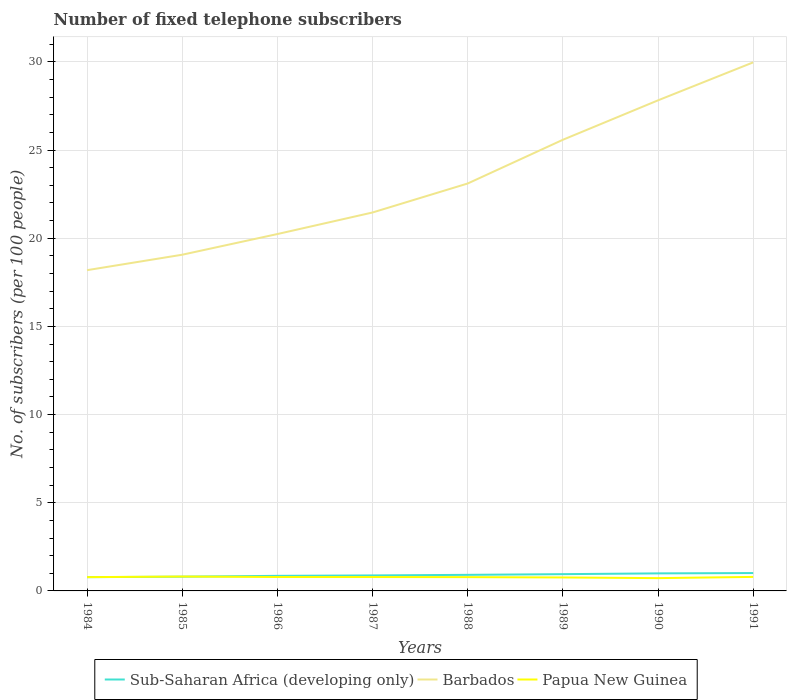Across all years, what is the maximum number of fixed telephone subscribers in Papua New Guinea?
Offer a terse response. 0.73. What is the total number of fixed telephone subscribers in Barbados in the graph?
Your response must be concise. -4.04. What is the difference between the highest and the second highest number of fixed telephone subscribers in Sub-Saharan Africa (developing only)?
Your answer should be compact. 0.23. What is the difference between the highest and the lowest number of fixed telephone subscribers in Barbados?
Your answer should be very brief. 3. Is the number of fixed telephone subscribers in Barbados strictly greater than the number of fixed telephone subscribers in Sub-Saharan Africa (developing only) over the years?
Make the answer very short. No. Are the values on the major ticks of Y-axis written in scientific E-notation?
Ensure brevity in your answer.  No. Does the graph contain grids?
Your answer should be very brief. Yes. How many legend labels are there?
Your response must be concise. 3. How are the legend labels stacked?
Offer a terse response. Horizontal. What is the title of the graph?
Provide a short and direct response. Number of fixed telephone subscribers. Does "Maldives" appear as one of the legend labels in the graph?
Your response must be concise. No. What is the label or title of the X-axis?
Your answer should be compact. Years. What is the label or title of the Y-axis?
Keep it short and to the point. No. of subscribers (per 100 people). What is the No. of subscribers (per 100 people) of Sub-Saharan Africa (developing only) in 1984?
Provide a short and direct response. 0.78. What is the No. of subscribers (per 100 people) in Barbados in 1984?
Keep it short and to the point. 18.19. What is the No. of subscribers (per 100 people) in Papua New Guinea in 1984?
Your answer should be compact. 0.78. What is the No. of subscribers (per 100 people) of Sub-Saharan Africa (developing only) in 1985?
Provide a succinct answer. 0.81. What is the No. of subscribers (per 100 people) in Barbados in 1985?
Your response must be concise. 19.06. What is the No. of subscribers (per 100 people) of Papua New Guinea in 1985?
Provide a succinct answer. 0.82. What is the No. of subscribers (per 100 people) of Sub-Saharan Africa (developing only) in 1986?
Offer a very short reply. 0.86. What is the No. of subscribers (per 100 people) in Barbados in 1986?
Keep it short and to the point. 20.24. What is the No. of subscribers (per 100 people) in Papua New Guinea in 1986?
Ensure brevity in your answer.  0.79. What is the No. of subscribers (per 100 people) of Sub-Saharan Africa (developing only) in 1987?
Make the answer very short. 0.88. What is the No. of subscribers (per 100 people) in Barbados in 1987?
Your answer should be very brief. 21.46. What is the No. of subscribers (per 100 people) of Papua New Guinea in 1987?
Offer a very short reply. 0.79. What is the No. of subscribers (per 100 people) of Sub-Saharan Africa (developing only) in 1988?
Your answer should be compact. 0.91. What is the No. of subscribers (per 100 people) of Barbados in 1988?
Offer a terse response. 23.1. What is the No. of subscribers (per 100 people) in Papua New Guinea in 1988?
Your response must be concise. 0.78. What is the No. of subscribers (per 100 people) in Sub-Saharan Africa (developing only) in 1989?
Ensure brevity in your answer.  0.95. What is the No. of subscribers (per 100 people) of Barbados in 1989?
Provide a short and direct response. 25.58. What is the No. of subscribers (per 100 people) of Papua New Guinea in 1989?
Give a very brief answer. 0.76. What is the No. of subscribers (per 100 people) of Sub-Saharan Africa (developing only) in 1990?
Your response must be concise. 1. What is the No. of subscribers (per 100 people) in Barbados in 1990?
Provide a succinct answer. 27.82. What is the No. of subscribers (per 100 people) in Papua New Guinea in 1990?
Your answer should be compact. 0.73. What is the No. of subscribers (per 100 people) in Sub-Saharan Africa (developing only) in 1991?
Your response must be concise. 1.01. What is the No. of subscribers (per 100 people) in Barbados in 1991?
Provide a short and direct response. 29.97. What is the No. of subscribers (per 100 people) in Papua New Guinea in 1991?
Your answer should be compact. 0.79. Across all years, what is the maximum No. of subscribers (per 100 people) in Sub-Saharan Africa (developing only)?
Your response must be concise. 1.01. Across all years, what is the maximum No. of subscribers (per 100 people) in Barbados?
Keep it short and to the point. 29.97. Across all years, what is the maximum No. of subscribers (per 100 people) in Papua New Guinea?
Offer a very short reply. 0.82. Across all years, what is the minimum No. of subscribers (per 100 people) in Sub-Saharan Africa (developing only)?
Your answer should be very brief. 0.78. Across all years, what is the minimum No. of subscribers (per 100 people) in Barbados?
Keep it short and to the point. 18.19. Across all years, what is the minimum No. of subscribers (per 100 people) of Papua New Guinea?
Provide a succinct answer. 0.73. What is the total No. of subscribers (per 100 people) in Sub-Saharan Africa (developing only) in the graph?
Give a very brief answer. 7.19. What is the total No. of subscribers (per 100 people) in Barbados in the graph?
Keep it short and to the point. 185.42. What is the total No. of subscribers (per 100 people) in Papua New Guinea in the graph?
Give a very brief answer. 6.24. What is the difference between the No. of subscribers (per 100 people) of Sub-Saharan Africa (developing only) in 1984 and that in 1985?
Ensure brevity in your answer.  -0.03. What is the difference between the No. of subscribers (per 100 people) in Barbados in 1984 and that in 1985?
Your answer should be compact. -0.88. What is the difference between the No. of subscribers (per 100 people) of Papua New Guinea in 1984 and that in 1985?
Make the answer very short. -0.03. What is the difference between the No. of subscribers (per 100 people) in Sub-Saharan Africa (developing only) in 1984 and that in 1986?
Your response must be concise. -0.07. What is the difference between the No. of subscribers (per 100 people) in Barbados in 1984 and that in 1986?
Offer a very short reply. -2.05. What is the difference between the No. of subscribers (per 100 people) of Papua New Guinea in 1984 and that in 1986?
Your answer should be compact. -0.01. What is the difference between the No. of subscribers (per 100 people) of Sub-Saharan Africa (developing only) in 1984 and that in 1987?
Provide a succinct answer. -0.1. What is the difference between the No. of subscribers (per 100 people) of Barbados in 1984 and that in 1987?
Give a very brief answer. -3.27. What is the difference between the No. of subscribers (per 100 people) of Papua New Guinea in 1984 and that in 1987?
Provide a succinct answer. -0.01. What is the difference between the No. of subscribers (per 100 people) in Sub-Saharan Africa (developing only) in 1984 and that in 1988?
Your answer should be very brief. -0.13. What is the difference between the No. of subscribers (per 100 people) in Barbados in 1984 and that in 1988?
Offer a very short reply. -4.91. What is the difference between the No. of subscribers (per 100 people) in Papua New Guinea in 1984 and that in 1988?
Give a very brief answer. -0. What is the difference between the No. of subscribers (per 100 people) in Sub-Saharan Africa (developing only) in 1984 and that in 1989?
Your response must be concise. -0.17. What is the difference between the No. of subscribers (per 100 people) of Barbados in 1984 and that in 1989?
Offer a very short reply. -7.39. What is the difference between the No. of subscribers (per 100 people) of Papua New Guinea in 1984 and that in 1989?
Your answer should be compact. 0.02. What is the difference between the No. of subscribers (per 100 people) of Sub-Saharan Africa (developing only) in 1984 and that in 1990?
Offer a very short reply. -0.21. What is the difference between the No. of subscribers (per 100 people) of Barbados in 1984 and that in 1990?
Provide a short and direct response. -9.63. What is the difference between the No. of subscribers (per 100 people) of Papua New Guinea in 1984 and that in 1990?
Your answer should be very brief. 0.06. What is the difference between the No. of subscribers (per 100 people) of Sub-Saharan Africa (developing only) in 1984 and that in 1991?
Your answer should be compact. -0.23. What is the difference between the No. of subscribers (per 100 people) in Barbados in 1984 and that in 1991?
Provide a succinct answer. -11.78. What is the difference between the No. of subscribers (per 100 people) in Papua New Guinea in 1984 and that in 1991?
Offer a very short reply. -0.01. What is the difference between the No. of subscribers (per 100 people) of Sub-Saharan Africa (developing only) in 1985 and that in 1986?
Provide a short and direct response. -0.05. What is the difference between the No. of subscribers (per 100 people) of Barbados in 1985 and that in 1986?
Your answer should be compact. -1.17. What is the difference between the No. of subscribers (per 100 people) of Papua New Guinea in 1985 and that in 1986?
Ensure brevity in your answer.  0.03. What is the difference between the No. of subscribers (per 100 people) in Sub-Saharan Africa (developing only) in 1985 and that in 1987?
Offer a terse response. -0.07. What is the difference between the No. of subscribers (per 100 people) in Barbados in 1985 and that in 1987?
Ensure brevity in your answer.  -2.39. What is the difference between the No. of subscribers (per 100 people) of Papua New Guinea in 1985 and that in 1987?
Your answer should be compact. 0.03. What is the difference between the No. of subscribers (per 100 people) of Sub-Saharan Africa (developing only) in 1985 and that in 1988?
Your answer should be very brief. -0.1. What is the difference between the No. of subscribers (per 100 people) in Barbados in 1985 and that in 1988?
Provide a short and direct response. -4.04. What is the difference between the No. of subscribers (per 100 people) in Papua New Guinea in 1985 and that in 1988?
Offer a terse response. 0.03. What is the difference between the No. of subscribers (per 100 people) of Sub-Saharan Africa (developing only) in 1985 and that in 1989?
Ensure brevity in your answer.  -0.14. What is the difference between the No. of subscribers (per 100 people) in Barbados in 1985 and that in 1989?
Ensure brevity in your answer.  -6.52. What is the difference between the No. of subscribers (per 100 people) of Papua New Guinea in 1985 and that in 1989?
Give a very brief answer. 0.05. What is the difference between the No. of subscribers (per 100 people) in Sub-Saharan Africa (developing only) in 1985 and that in 1990?
Make the answer very short. -0.19. What is the difference between the No. of subscribers (per 100 people) in Barbados in 1985 and that in 1990?
Give a very brief answer. -8.75. What is the difference between the No. of subscribers (per 100 people) in Papua New Guinea in 1985 and that in 1990?
Offer a very short reply. 0.09. What is the difference between the No. of subscribers (per 100 people) in Sub-Saharan Africa (developing only) in 1985 and that in 1991?
Provide a short and direct response. -0.21. What is the difference between the No. of subscribers (per 100 people) in Barbados in 1985 and that in 1991?
Ensure brevity in your answer.  -10.91. What is the difference between the No. of subscribers (per 100 people) of Papua New Guinea in 1985 and that in 1991?
Your response must be concise. 0.02. What is the difference between the No. of subscribers (per 100 people) in Sub-Saharan Africa (developing only) in 1986 and that in 1987?
Offer a very short reply. -0.02. What is the difference between the No. of subscribers (per 100 people) in Barbados in 1986 and that in 1987?
Provide a short and direct response. -1.22. What is the difference between the No. of subscribers (per 100 people) in Papua New Guinea in 1986 and that in 1987?
Provide a short and direct response. 0. What is the difference between the No. of subscribers (per 100 people) of Sub-Saharan Africa (developing only) in 1986 and that in 1988?
Give a very brief answer. -0.06. What is the difference between the No. of subscribers (per 100 people) of Barbados in 1986 and that in 1988?
Ensure brevity in your answer.  -2.87. What is the difference between the No. of subscribers (per 100 people) in Papua New Guinea in 1986 and that in 1988?
Keep it short and to the point. 0.01. What is the difference between the No. of subscribers (per 100 people) of Sub-Saharan Africa (developing only) in 1986 and that in 1989?
Your response must be concise. -0.1. What is the difference between the No. of subscribers (per 100 people) of Barbados in 1986 and that in 1989?
Your response must be concise. -5.35. What is the difference between the No. of subscribers (per 100 people) of Papua New Guinea in 1986 and that in 1989?
Offer a very short reply. 0.02. What is the difference between the No. of subscribers (per 100 people) in Sub-Saharan Africa (developing only) in 1986 and that in 1990?
Offer a very short reply. -0.14. What is the difference between the No. of subscribers (per 100 people) in Barbados in 1986 and that in 1990?
Keep it short and to the point. -7.58. What is the difference between the No. of subscribers (per 100 people) of Papua New Guinea in 1986 and that in 1990?
Give a very brief answer. 0.06. What is the difference between the No. of subscribers (per 100 people) of Sub-Saharan Africa (developing only) in 1986 and that in 1991?
Ensure brevity in your answer.  -0.16. What is the difference between the No. of subscribers (per 100 people) in Barbados in 1986 and that in 1991?
Your answer should be compact. -9.74. What is the difference between the No. of subscribers (per 100 people) in Papua New Guinea in 1986 and that in 1991?
Make the answer very short. -0.01. What is the difference between the No. of subscribers (per 100 people) of Sub-Saharan Africa (developing only) in 1987 and that in 1988?
Offer a very short reply. -0.03. What is the difference between the No. of subscribers (per 100 people) of Barbados in 1987 and that in 1988?
Offer a terse response. -1.64. What is the difference between the No. of subscribers (per 100 people) of Papua New Guinea in 1987 and that in 1988?
Your answer should be compact. 0. What is the difference between the No. of subscribers (per 100 people) in Sub-Saharan Africa (developing only) in 1987 and that in 1989?
Ensure brevity in your answer.  -0.07. What is the difference between the No. of subscribers (per 100 people) of Barbados in 1987 and that in 1989?
Make the answer very short. -4.12. What is the difference between the No. of subscribers (per 100 people) of Papua New Guinea in 1987 and that in 1989?
Provide a short and direct response. 0.02. What is the difference between the No. of subscribers (per 100 people) of Sub-Saharan Africa (developing only) in 1987 and that in 1990?
Offer a very short reply. -0.12. What is the difference between the No. of subscribers (per 100 people) in Barbados in 1987 and that in 1990?
Offer a very short reply. -6.36. What is the difference between the No. of subscribers (per 100 people) in Papua New Guinea in 1987 and that in 1990?
Offer a terse response. 0.06. What is the difference between the No. of subscribers (per 100 people) in Sub-Saharan Africa (developing only) in 1987 and that in 1991?
Your answer should be compact. -0.13. What is the difference between the No. of subscribers (per 100 people) in Barbados in 1987 and that in 1991?
Offer a terse response. -8.51. What is the difference between the No. of subscribers (per 100 people) in Papua New Guinea in 1987 and that in 1991?
Offer a terse response. -0.01. What is the difference between the No. of subscribers (per 100 people) of Sub-Saharan Africa (developing only) in 1988 and that in 1989?
Offer a terse response. -0.04. What is the difference between the No. of subscribers (per 100 people) in Barbados in 1988 and that in 1989?
Offer a terse response. -2.48. What is the difference between the No. of subscribers (per 100 people) of Papua New Guinea in 1988 and that in 1989?
Give a very brief answer. 0.02. What is the difference between the No. of subscribers (per 100 people) of Sub-Saharan Africa (developing only) in 1988 and that in 1990?
Offer a terse response. -0.08. What is the difference between the No. of subscribers (per 100 people) in Barbados in 1988 and that in 1990?
Give a very brief answer. -4.72. What is the difference between the No. of subscribers (per 100 people) of Papua New Guinea in 1988 and that in 1990?
Your response must be concise. 0.06. What is the difference between the No. of subscribers (per 100 people) of Sub-Saharan Africa (developing only) in 1988 and that in 1991?
Make the answer very short. -0.1. What is the difference between the No. of subscribers (per 100 people) of Barbados in 1988 and that in 1991?
Your response must be concise. -6.87. What is the difference between the No. of subscribers (per 100 people) in Papua New Guinea in 1988 and that in 1991?
Your response must be concise. -0.01. What is the difference between the No. of subscribers (per 100 people) of Sub-Saharan Africa (developing only) in 1989 and that in 1990?
Your answer should be compact. -0.04. What is the difference between the No. of subscribers (per 100 people) of Barbados in 1989 and that in 1990?
Your response must be concise. -2.24. What is the difference between the No. of subscribers (per 100 people) of Papua New Guinea in 1989 and that in 1990?
Your answer should be very brief. 0.04. What is the difference between the No. of subscribers (per 100 people) of Sub-Saharan Africa (developing only) in 1989 and that in 1991?
Offer a terse response. -0.06. What is the difference between the No. of subscribers (per 100 people) in Barbados in 1989 and that in 1991?
Provide a succinct answer. -4.39. What is the difference between the No. of subscribers (per 100 people) in Papua New Guinea in 1989 and that in 1991?
Your answer should be compact. -0.03. What is the difference between the No. of subscribers (per 100 people) in Sub-Saharan Africa (developing only) in 1990 and that in 1991?
Make the answer very short. -0.02. What is the difference between the No. of subscribers (per 100 people) of Barbados in 1990 and that in 1991?
Your answer should be compact. -2.15. What is the difference between the No. of subscribers (per 100 people) in Papua New Guinea in 1990 and that in 1991?
Your response must be concise. -0.07. What is the difference between the No. of subscribers (per 100 people) of Sub-Saharan Africa (developing only) in 1984 and the No. of subscribers (per 100 people) of Barbados in 1985?
Your answer should be compact. -18.28. What is the difference between the No. of subscribers (per 100 people) in Sub-Saharan Africa (developing only) in 1984 and the No. of subscribers (per 100 people) in Papua New Guinea in 1985?
Your answer should be very brief. -0.03. What is the difference between the No. of subscribers (per 100 people) in Barbados in 1984 and the No. of subscribers (per 100 people) in Papua New Guinea in 1985?
Keep it short and to the point. 17.37. What is the difference between the No. of subscribers (per 100 people) of Sub-Saharan Africa (developing only) in 1984 and the No. of subscribers (per 100 people) of Barbados in 1986?
Offer a terse response. -19.45. What is the difference between the No. of subscribers (per 100 people) of Sub-Saharan Africa (developing only) in 1984 and the No. of subscribers (per 100 people) of Papua New Guinea in 1986?
Offer a very short reply. -0.01. What is the difference between the No. of subscribers (per 100 people) in Barbados in 1984 and the No. of subscribers (per 100 people) in Papua New Guinea in 1986?
Offer a very short reply. 17.4. What is the difference between the No. of subscribers (per 100 people) in Sub-Saharan Africa (developing only) in 1984 and the No. of subscribers (per 100 people) in Barbados in 1987?
Offer a very short reply. -20.68. What is the difference between the No. of subscribers (per 100 people) of Sub-Saharan Africa (developing only) in 1984 and the No. of subscribers (per 100 people) of Papua New Guinea in 1987?
Your answer should be very brief. -0.01. What is the difference between the No. of subscribers (per 100 people) in Barbados in 1984 and the No. of subscribers (per 100 people) in Papua New Guinea in 1987?
Your answer should be very brief. 17.4. What is the difference between the No. of subscribers (per 100 people) in Sub-Saharan Africa (developing only) in 1984 and the No. of subscribers (per 100 people) in Barbados in 1988?
Your answer should be compact. -22.32. What is the difference between the No. of subscribers (per 100 people) of Sub-Saharan Africa (developing only) in 1984 and the No. of subscribers (per 100 people) of Papua New Guinea in 1988?
Offer a terse response. -0. What is the difference between the No. of subscribers (per 100 people) of Barbados in 1984 and the No. of subscribers (per 100 people) of Papua New Guinea in 1988?
Provide a short and direct response. 17.41. What is the difference between the No. of subscribers (per 100 people) of Sub-Saharan Africa (developing only) in 1984 and the No. of subscribers (per 100 people) of Barbados in 1989?
Give a very brief answer. -24.8. What is the difference between the No. of subscribers (per 100 people) in Sub-Saharan Africa (developing only) in 1984 and the No. of subscribers (per 100 people) in Papua New Guinea in 1989?
Keep it short and to the point. 0.02. What is the difference between the No. of subscribers (per 100 people) of Barbados in 1984 and the No. of subscribers (per 100 people) of Papua New Guinea in 1989?
Make the answer very short. 17.42. What is the difference between the No. of subscribers (per 100 people) in Sub-Saharan Africa (developing only) in 1984 and the No. of subscribers (per 100 people) in Barbados in 1990?
Provide a short and direct response. -27.04. What is the difference between the No. of subscribers (per 100 people) of Sub-Saharan Africa (developing only) in 1984 and the No. of subscribers (per 100 people) of Papua New Guinea in 1990?
Make the answer very short. 0.05. What is the difference between the No. of subscribers (per 100 people) in Barbados in 1984 and the No. of subscribers (per 100 people) in Papua New Guinea in 1990?
Give a very brief answer. 17.46. What is the difference between the No. of subscribers (per 100 people) of Sub-Saharan Africa (developing only) in 1984 and the No. of subscribers (per 100 people) of Barbados in 1991?
Provide a succinct answer. -29.19. What is the difference between the No. of subscribers (per 100 people) of Sub-Saharan Africa (developing only) in 1984 and the No. of subscribers (per 100 people) of Papua New Guinea in 1991?
Ensure brevity in your answer.  -0.01. What is the difference between the No. of subscribers (per 100 people) in Barbados in 1984 and the No. of subscribers (per 100 people) in Papua New Guinea in 1991?
Provide a short and direct response. 17.39. What is the difference between the No. of subscribers (per 100 people) of Sub-Saharan Africa (developing only) in 1985 and the No. of subscribers (per 100 people) of Barbados in 1986?
Your answer should be compact. -19.43. What is the difference between the No. of subscribers (per 100 people) in Sub-Saharan Africa (developing only) in 1985 and the No. of subscribers (per 100 people) in Papua New Guinea in 1986?
Keep it short and to the point. 0.02. What is the difference between the No. of subscribers (per 100 people) in Barbados in 1985 and the No. of subscribers (per 100 people) in Papua New Guinea in 1986?
Offer a very short reply. 18.27. What is the difference between the No. of subscribers (per 100 people) of Sub-Saharan Africa (developing only) in 1985 and the No. of subscribers (per 100 people) of Barbados in 1987?
Make the answer very short. -20.65. What is the difference between the No. of subscribers (per 100 people) in Sub-Saharan Africa (developing only) in 1985 and the No. of subscribers (per 100 people) in Papua New Guinea in 1987?
Offer a very short reply. 0.02. What is the difference between the No. of subscribers (per 100 people) in Barbados in 1985 and the No. of subscribers (per 100 people) in Papua New Guinea in 1987?
Give a very brief answer. 18.28. What is the difference between the No. of subscribers (per 100 people) of Sub-Saharan Africa (developing only) in 1985 and the No. of subscribers (per 100 people) of Barbados in 1988?
Make the answer very short. -22.29. What is the difference between the No. of subscribers (per 100 people) of Sub-Saharan Africa (developing only) in 1985 and the No. of subscribers (per 100 people) of Papua New Guinea in 1988?
Offer a very short reply. 0.03. What is the difference between the No. of subscribers (per 100 people) of Barbados in 1985 and the No. of subscribers (per 100 people) of Papua New Guinea in 1988?
Ensure brevity in your answer.  18.28. What is the difference between the No. of subscribers (per 100 people) in Sub-Saharan Africa (developing only) in 1985 and the No. of subscribers (per 100 people) in Barbados in 1989?
Offer a terse response. -24.77. What is the difference between the No. of subscribers (per 100 people) of Sub-Saharan Africa (developing only) in 1985 and the No. of subscribers (per 100 people) of Papua New Guinea in 1989?
Your answer should be very brief. 0.04. What is the difference between the No. of subscribers (per 100 people) of Barbados in 1985 and the No. of subscribers (per 100 people) of Papua New Guinea in 1989?
Offer a very short reply. 18.3. What is the difference between the No. of subscribers (per 100 people) in Sub-Saharan Africa (developing only) in 1985 and the No. of subscribers (per 100 people) in Barbados in 1990?
Provide a succinct answer. -27.01. What is the difference between the No. of subscribers (per 100 people) in Sub-Saharan Africa (developing only) in 1985 and the No. of subscribers (per 100 people) in Papua New Guinea in 1990?
Provide a succinct answer. 0.08. What is the difference between the No. of subscribers (per 100 people) of Barbados in 1985 and the No. of subscribers (per 100 people) of Papua New Guinea in 1990?
Provide a short and direct response. 18.34. What is the difference between the No. of subscribers (per 100 people) in Sub-Saharan Africa (developing only) in 1985 and the No. of subscribers (per 100 people) in Barbados in 1991?
Provide a short and direct response. -29.16. What is the difference between the No. of subscribers (per 100 people) in Sub-Saharan Africa (developing only) in 1985 and the No. of subscribers (per 100 people) in Papua New Guinea in 1991?
Provide a succinct answer. 0.01. What is the difference between the No. of subscribers (per 100 people) of Barbados in 1985 and the No. of subscribers (per 100 people) of Papua New Guinea in 1991?
Your answer should be very brief. 18.27. What is the difference between the No. of subscribers (per 100 people) of Sub-Saharan Africa (developing only) in 1986 and the No. of subscribers (per 100 people) of Barbados in 1987?
Your answer should be compact. -20.6. What is the difference between the No. of subscribers (per 100 people) of Sub-Saharan Africa (developing only) in 1986 and the No. of subscribers (per 100 people) of Papua New Guinea in 1987?
Your answer should be very brief. 0.07. What is the difference between the No. of subscribers (per 100 people) in Barbados in 1986 and the No. of subscribers (per 100 people) in Papua New Guinea in 1987?
Give a very brief answer. 19.45. What is the difference between the No. of subscribers (per 100 people) in Sub-Saharan Africa (developing only) in 1986 and the No. of subscribers (per 100 people) in Barbados in 1988?
Offer a terse response. -22.25. What is the difference between the No. of subscribers (per 100 people) in Sub-Saharan Africa (developing only) in 1986 and the No. of subscribers (per 100 people) in Papua New Guinea in 1988?
Provide a short and direct response. 0.07. What is the difference between the No. of subscribers (per 100 people) in Barbados in 1986 and the No. of subscribers (per 100 people) in Papua New Guinea in 1988?
Provide a succinct answer. 19.45. What is the difference between the No. of subscribers (per 100 people) of Sub-Saharan Africa (developing only) in 1986 and the No. of subscribers (per 100 people) of Barbados in 1989?
Give a very brief answer. -24.73. What is the difference between the No. of subscribers (per 100 people) of Sub-Saharan Africa (developing only) in 1986 and the No. of subscribers (per 100 people) of Papua New Guinea in 1989?
Your response must be concise. 0.09. What is the difference between the No. of subscribers (per 100 people) in Barbados in 1986 and the No. of subscribers (per 100 people) in Papua New Guinea in 1989?
Your answer should be very brief. 19.47. What is the difference between the No. of subscribers (per 100 people) in Sub-Saharan Africa (developing only) in 1986 and the No. of subscribers (per 100 people) in Barbados in 1990?
Your answer should be compact. -26.96. What is the difference between the No. of subscribers (per 100 people) of Sub-Saharan Africa (developing only) in 1986 and the No. of subscribers (per 100 people) of Papua New Guinea in 1990?
Your response must be concise. 0.13. What is the difference between the No. of subscribers (per 100 people) in Barbados in 1986 and the No. of subscribers (per 100 people) in Papua New Guinea in 1990?
Your response must be concise. 19.51. What is the difference between the No. of subscribers (per 100 people) in Sub-Saharan Africa (developing only) in 1986 and the No. of subscribers (per 100 people) in Barbados in 1991?
Give a very brief answer. -29.12. What is the difference between the No. of subscribers (per 100 people) of Sub-Saharan Africa (developing only) in 1986 and the No. of subscribers (per 100 people) of Papua New Guinea in 1991?
Offer a terse response. 0.06. What is the difference between the No. of subscribers (per 100 people) of Barbados in 1986 and the No. of subscribers (per 100 people) of Papua New Guinea in 1991?
Your response must be concise. 19.44. What is the difference between the No. of subscribers (per 100 people) of Sub-Saharan Africa (developing only) in 1987 and the No. of subscribers (per 100 people) of Barbados in 1988?
Make the answer very short. -22.22. What is the difference between the No. of subscribers (per 100 people) in Sub-Saharan Africa (developing only) in 1987 and the No. of subscribers (per 100 people) in Papua New Guinea in 1988?
Provide a short and direct response. 0.1. What is the difference between the No. of subscribers (per 100 people) in Barbados in 1987 and the No. of subscribers (per 100 people) in Papua New Guinea in 1988?
Give a very brief answer. 20.68. What is the difference between the No. of subscribers (per 100 people) of Sub-Saharan Africa (developing only) in 1987 and the No. of subscribers (per 100 people) of Barbados in 1989?
Ensure brevity in your answer.  -24.7. What is the difference between the No. of subscribers (per 100 people) in Sub-Saharan Africa (developing only) in 1987 and the No. of subscribers (per 100 people) in Papua New Guinea in 1989?
Offer a very short reply. 0.12. What is the difference between the No. of subscribers (per 100 people) in Barbados in 1987 and the No. of subscribers (per 100 people) in Papua New Guinea in 1989?
Your answer should be compact. 20.69. What is the difference between the No. of subscribers (per 100 people) in Sub-Saharan Africa (developing only) in 1987 and the No. of subscribers (per 100 people) in Barbados in 1990?
Offer a very short reply. -26.94. What is the difference between the No. of subscribers (per 100 people) in Sub-Saharan Africa (developing only) in 1987 and the No. of subscribers (per 100 people) in Papua New Guinea in 1990?
Your answer should be compact. 0.15. What is the difference between the No. of subscribers (per 100 people) in Barbados in 1987 and the No. of subscribers (per 100 people) in Papua New Guinea in 1990?
Your response must be concise. 20.73. What is the difference between the No. of subscribers (per 100 people) of Sub-Saharan Africa (developing only) in 1987 and the No. of subscribers (per 100 people) of Barbados in 1991?
Your answer should be compact. -29.09. What is the difference between the No. of subscribers (per 100 people) of Sub-Saharan Africa (developing only) in 1987 and the No. of subscribers (per 100 people) of Papua New Guinea in 1991?
Keep it short and to the point. 0.08. What is the difference between the No. of subscribers (per 100 people) in Barbados in 1987 and the No. of subscribers (per 100 people) in Papua New Guinea in 1991?
Your answer should be very brief. 20.66. What is the difference between the No. of subscribers (per 100 people) in Sub-Saharan Africa (developing only) in 1988 and the No. of subscribers (per 100 people) in Barbados in 1989?
Make the answer very short. -24.67. What is the difference between the No. of subscribers (per 100 people) in Sub-Saharan Africa (developing only) in 1988 and the No. of subscribers (per 100 people) in Papua New Guinea in 1989?
Provide a succinct answer. 0.15. What is the difference between the No. of subscribers (per 100 people) of Barbados in 1988 and the No. of subscribers (per 100 people) of Papua New Guinea in 1989?
Make the answer very short. 22.34. What is the difference between the No. of subscribers (per 100 people) of Sub-Saharan Africa (developing only) in 1988 and the No. of subscribers (per 100 people) of Barbados in 1990?
Keep it short and to the point. -26.91. What is the difference between the No. of subscribers (per 100 people) in Sub-Saharan Africa (developing only) in 1988 and the No. of subscribers (per 100 people) in Papua New Guinea in 1990?
Make the answer very short. 0.19. What is the difference between the No. of subscribers (per 100 people) in Barbados in 1988 and the No. of subscribers (per 100 people) in Papua New Guinea in 1990?
Offer a terse response. 22.38. What is the difference between the No. of subscribers (per 100 people) of Sub-Saharan Africa (developing only) in 1988 and the No. of subscribers (per 100 people) of Barbados in 1991?
Offer a terse response. -29.06. What is the difference between the No. of subscribers (per 100 people) of Sub-Saharan Africa (developing only) in 1988 and the No. of subscribers (per 100 people) of Papua New Guinea in 1991?
Keep it short and to the point. 0.12. What is the difference between the No. of subscribers (per 100 people) of Barbados in 1988 and the No. of subscribers (per 100 people) of Papua New Guinea in 1991?
Offer a very short reply. 22.31. What is the difference between the No. of subscribers (per 100 people) of Sub-Saharan Africa (developing only) in 1989 and the No. of subscribers (per 100 people) of Barbados in 1990?
Make the answer very short. -26.87. What is the difference between the No. of subscribers (per 100 people) in Sub-Saharan Africa (developing only) in 1989 and the No. of subscribers (per 100 people) in Papua New Guinea in 1990?
Your answer should be compact. 0.22. What is the difference between the No. of subscribers (per 100 people) in Barbados in 1989 and the No. of subscribers (per 100 people) in Papua New Guinea in 1990?
Your response must be concise. 24.86. What is the difference between the No. of subscribers (per 100 people) of Sub-Saharan Africa (developing only) in 1989 and the No. of subscribers (per 100 people) of Barbados in 1991?
Provide a succinct answer. -29.02. What is the difference between the No. of subscribers (per 100 people) of Sub-Saharan Africa (developing only) in 1989 and the No. of subscribers (per 100 people) of Papua New Guinea in 1991?
Ensure brevity in your answer.  0.16. What is the difference between the No. of subscribers (per 100 people) of Barbados in 1989 and the No. of subscribers (per 100 people) of Papua New Guinea in 1991?
Keep it short and to the point. 24.79. What is the difference between the No. of subscribers (per 100 people) of Sub-Saharan Africa (developing only) in 1990 and the No. of subscribers (per 100 people) of Barbados in 1991?
Provide a succinct answer. -28.98. What is the difference between the No. of subscribers (per 100 people) in Sub-Saharan Africa (developing only) in 1990 and the No. of subscribers (per 100 people) in Papua New Guinea in 1991?
Provide a short and direct response. 0.2. What is the difference between the No. of subscribers (per 100 people) in Barbados in 1990 and the No. of subscribers (per 100 people) in Papua New Guinea in 1991?
Ensure brevity in your answer.  27.02. What is the average No. of subscribers (per 100 people) in Sub-Saharan Africa (developing only) per year?
Offer a very short reply. 0.9. What is the average No. of subscribers (per 100 people) in Barbados per year?
Offer a terse response. 23.18. What is the average No. of subscribers (per 100 people) of Papua New Guinea per year?
Provide a succinct answer. 0.78. In the year 1984, what is the difference between the No. of subscribers (per 100 people) in Sub-Saharan Africa (developing only) and No. of subscribers (per 100 people) in Barbados?
Your response must be concise. -17.41. In the year 1984, what is the difference between the No. of subscribers (per 100 people) of Sub-Saharan Africa (developing only) and No. of subscribers (per 100 people) of Papua New Guinea?
Offer a very short reply. -0. In the year 1984, what is the difference between the No. of subscribers (per 100 people) in Barbados and No. of subscribers (per 100 people) in Papua New Guinea?
Provide a short and direct response. 17.41. In the year 1985, what is the difference between the No. of subscribers (per 100 people) in Sub-Saharan Africa (developing only) and No. of subscribers (per 100 people) in Barbados?
Your answer should be very brief. -18.26. In the year 1985, what is the difference between the No. of subscribers (per 100 people) in Sub-Saharan Africa (developing only) and No. of subscribers (per 100 people) in Papua New Guinea?
Provide a short and direct response. -0.01. In the year 1985, what is the difference between the No. of subscribers (per 100 people) in Barbados and No. of subscribers (per 100 people) in Papua New Guinea?
Make the answer very short. 18.25. In the year 1986, what is the difference between the No. of subscribers (per 100 people) of Sub-Saharan Africa (developing only) and No. of subscribers (per 100 people) of Barbados?
Ensure brevity in your answer.  -19.38. In the year 1986, what is the difference between the No. of subscribers (per 100 people) in Sub-Saharan Africa (developing only) and No. of subscribers (per 100 people) in Papua New Guinea?
Offer a very short reply. 0.07. In the year 1986, what is the difference between the No. of subscribers (per 100 people) in Barbados and No. of subscribers (per 100 people) in Papua New Guinea?
Your response must be concise. 19.45. In the year 1987, what is the difference between the No. of subscribers (per 100 people) of Sub-Saharan Africa (developing only) and No. of subscribers (per 100 people) of Barbados?
Offer a terse response. -20.58. In the year 1987, what is the difference between the No. of subscribers (per 100 people) in Sub-Saharan Africa (developing only) and No. of subscribers (per 100 people) in Papua New Guinea?
Your answer should be compact. 0.09. In the year 1987, what is the difference between the No. of subscribers (per 100 people) of Barbados and No. of subscribers (per 100 people) of Papua New Guinea?
Ensure brevity in your answer.  20.67. In the year 1988, what is the difference between the No. of subscribers (per 100 people) in Sub-Saharan Africa (developing only) and No. of subscribers (per 100 people) in Barbados?
Your answer should be very brief. -22.19. In the year 1988, what is the difference between the No. of subscribers (per 100 people) in Sub-Saharan Africa (developing only) and No. of subscribers (per 100 people) in Papua New Guinea?
Ensure brevity in your answer.  0.13. In the year 1988, what is the difference between the No. of subscribers (per 100 people) in Barbados and No. of subscribers (per 100 people) in Papua New Guinea?
Offer a very short reply. 22.32. In the year 1989, what is the difference between the No. of subscribers (per 100 people) of Sub-Saharan Africa (developing only) and No. of subscribers (per 100 people) of Barbados?
Keep it short and to the point. -24.63. In the year 1989, what is the difference between the No. of subscribers (per 100 people) of Sub-Saharan Africa (developing only) and No. of subscribers (per 100 people) of Papua New Guinea?
Make the answer very short. 0.19. In the year 1989, what is the difference between the No. of subscribers (per 100 people) of Barbados and No. of subscribers (per 100 people) of Papua New Guinea?
Offer a terse response. 24.82. In the year 1990, what is the difference between the No. of subscribers (per 100 people) in Sub-Saharan Africa (developing only) and No. of subscribers (per 100 people) in Barbados?
Offer a terse response. -26.82. In the year 1990, what is the difference between the No. of subscribers (per 100 people) of Sub-Saharan Africa (developing only) and No. of subscribers (per 100 people) of Papua New Guinea?
Keep it short and to the point. 0.27. In the year 1990, what is the difference between the No. of subscribers (per 100 people) of Barbados and No. of subscribers (per 100 people) of Papua New Guinea?
Provide a short and direct response. 27.09. In the year 1991, what is the difference between the No. of subscribers (per 100 people) of Sub-Saharan Africa (developing only) and No. of subscribers (per 100 people) of Barbados?
Your answer should be very brief. -28.96. In the year 1991, what is the difference between the No. of subscribers (per 100 people) of Sub-Saharan Africa (developing only) and No. of subscribers (per 100 people) of Papua New Guinea?
Your response must be concise. 0.22. In the year 1991, what is the difference between the No. of subscribers (per 100 people) in Barbados and No. of subscribers (per 100 people) in Papua New Guinea?
Offer a terse response. 29.18. What is the ratio of the No. of subscribers (per 100 people) in Sub-Saharan Africa (developing only) in 1984 to that in 1985?
Provide a succinct answer. 0.97. What is the ratio of the No. of subscribers (per 100 people) in Barbados in 1984 to that in 1985?
Give a very brief answer. 0.95. What is the ratio of the No. of subscribers (per 100 people) in Papua New Guinea in 1984 to that in 1985?
Ensure brevity in your answer.  0.96. What is the ratio of the No. of subscribers (per 100 people) of Sub-Saharan Africa (developing only) in 1984 to that in 1986?
Give a very brief answer. 0.91. What is the ratio of the No. of subscribers (per 100 people) of Barbados in 1984 to that in 1986?
Keep it short and to the point. 0.9. What is the ratio of the No. of subscribers (per 100 people) in Sub-Saharan Africa (developing only) in 1984 to that in 1987?
Provide a succinct answer. 0.89. What is the ratio of the No. of subscribers (per 100 people) in Barbados in 1984 to that in 1987?
Ensure brevity in your answer.  0.85. What is the ratio of the No. of subscribers (per 100 people) of Sub-Saharan Africa (developing only) in 1984 to that in 1988?
Offer a very short reply. 0.86. What is the ratio of the No. of subscribers (per 100 people) of Barbados in 1984 to that in 1988?
Make the answer very short. 0.79. What is the ratio of the No. of subscribers (per 100 people) in Sub-Saharan Africa (developing only) in 1984 to that in 1989?
Offer a terse response. 0.82. What is the ratio of the No. of subscribers (per 100 people) in Barbados in 1984 to that in 1989?
Offer a very short reply. 0.71. What is the ratio of the No. of subscribers (per 100 people) in Papua New Guinea in 1984 to that in 1989?
Provide a succinct answer. 1.02. What is the ratio of the No. of subscribers (per 100 people) in Sub-Saharan Africa (developing only) in 1984 to that in 1990?
Keep it short and to the point. 0.78. What is the ratio of the No. of subscribers (per 100 people) of Barbados in 1984 to that in 1990?
Provide a succinct answer. 0.65. What is the ratio of the No. of subscribers (per 100 people) of Papua New Guinea in 1984 to that in 1990?
Offer a terse response. 1.08. What is the ratio of the No. of subscribers (per 100 people) of Sub-Saharan Africa (developing only) in 1984 to that in 1991?
Make the answer very short. 0.77. What is the ratio of the No. of subscribers (per 100 people) of Barbados in 1984 to that in 1991?
Ensure brevity in your answer.  0.61. What is the ratio of the No. of subscribers (per 100 people) of Papua New Guinea in 1984 to that in 1991?
Give a very brief answer. 0.98. What is the ratio of the No. of subscribers (per 100 people) in Sub-Saharan Africa (developing only) in 1985 to that in 1986?
Offer a very short reply. 0.94. What is the ratio of the No. of subscribers (per 100 people) of Barbados in 1985 to that in 1986?
Your response must be concise. 0.94. What is the ratio of the No. of subscribers (per 100 people) of Papua New Guinea in 1985 to that in 1986?
Your answer should be compact. 1.03. What is the ratio of the No. of subscribers (per 100 people) in Sub-Saharan Africa (developing only) in 1985 to that in 1987?
Keep it short and to the point. 0.92. What is the ratio of the No. of subscribers (per 100 people) in Barbados in 1985 to that in 1987?
Make the answer very short. 0.89. What is the ratio of the No. of subscribers (per 100 people) of Papua New Guinea in 1985 to that in 1987?
Keep it short and to the point. 1.04. What is the ratio of the No. of subscribers (per 100 people) in Sub-Saharan Africa (developing only) in 1985 to that in 1988?
Offer a very short reply. 0.89. What is the ratio of the No. of subscribers (per 100 people) in Barbados in 1985 to that in 1988?
Provide a succinct answer. 0.83. What is the ratio of the No. of subscribers (per 100 people) of Papua New Guinea in 1985 to that in 1988?
Provide a succinct answer. 1.04. What is the ratio of the No. of subscribers (per 100 people) of Sub-Saharan Africa (developing only) in 1985 to that in 1989?
Ensure brevity in your answer.  0.85. What is the ratio of the No. of subscribers (per 100 people) of Barbados in 1985 to that in 1989?
Offer a very short reply. 0.75. What is the ratio of the No. of subscribers (per 100 people) in Papua New Guinea in 1985 to that in 1989?
Provide a short and direct response. 1.07. What is the ratio of the No. of subscribers (per 100 people) of Sub-Saharan Africa (developing only) in 1985 to that in 1990?
Provide a short and direct response. 0.81. What is the ratio of the No. of subscribers (per 100 people) of Barbados in 1985 to that in 1990?
Offer a terse response. 0.69. What is the ratio of the No. of subscribers (per 100 people) in Papua New Guinea in 1985 to that in 1990?
Give a very brief answer. 1.12. What is the ratio of the No. of subscribers (per 100 people) of Sub-Saharan Africa (developing only) in 1985 to that in 1991?
Your answer should be compact. 0.8. What is the ratio of the No. of subscribers (per 100 people) of Barbados in 1985 to that in 1991?
Your response must be concise. 0.64. What is the ratio of the No. of subscribers (per 100 people) of Papua New Guinea in 1985 to that in 1991?
Your answer should be compact. 1.03. What is the ratio of the No. of subscribers (per 100 people) in Sub-Saharan Africa (developing only) in 1986 to that in 1987?
Provide a short and direct response. 0.97. What is the ratio of the No. of subscribers (per 100 people) of Barbados in 1986 to that in 1987?
Your answer should be compact. 0.94. What is the ratio of the No. of subscribers (per 100 people) in Papua New Guinea in 1986 to that in 1987?
Offer a terse response. 1. What is the ratio of the No. of subscribers (per 100 people) of Sub-Saharan Africa (developing only) in 1986 to that in 1988?
Ensure brevity in your answer.  0.94. What is the ratio of the No. of subscribers (per 100 people) in Barbados in 1986 to that in 1988?
Provide a short and direct response. 0.88. What is the ratio of the No. of subscribers (per 100 people) in Papua New Guinea in 1986 to that in 1988?
Give a very brief answer. 1.01. What is the ratio of the No. of subscribers (per 100 people) in Sub-Saharan Africa (developing only) in 1986 to that in 1989?
Give a very brief answer. 0.9. What is the ratio of the No. of subscribers (per 100 people) of Barbados in 1986 to that in 1989?
Your answer should be very brief. 0.79. What is the ratio of the No. of subscribers (per 100 people) of Papua New Guinea in 1986 to that in 1989?
Keep it short and to the point. 1.03. What is the ratio of the No. of subscribers (per 100 people) in Sub-Saharan Africa (developing only) in 1986 to that in 1990?
Make the answer very short. 0.86. What is the ratio of the No. of subscribers (per 100 people) of Barbados in 1986 to that in 1990?
Provide a succinct answer. 0.73. What is the ratio of the No. of subscribers (per 100 people) of Papua New Guinea in 1986 to that in 1990?
Your answer should be compact. 1.09. What is the ratio of the No. of subscribers (per 100 people) of Sub-Saharan Africa (developing only) in 1986 to that in 1991?
Your answer should be very brief. 0.84. What is the ratio of the No. of subscribers (per 100 people) in Barbados in 1986 to that in 1991?
Offer a very short reply. 0.68. What is the ratio of the No. of subscribers (per 100 people) in Sub-Saharan Africa (developing only) in 1987 to that in 1988?
Your answer should be very brief. 0.96. What is the ratio of the No. of subscribers (per 100 people) in Barbados in 1987 to that in 1988?
Keep it short and to the point. 0.93. What is the ratio of the No. of subscribers (per 100 people) of Papua New Guinea in 1987 to that in 1988?
Provide a short and direct response. 1.01. What is the ratio of the No. of subscribers (per 100 people) in Sub-Saharan Africa (developing only) in 1987 to that in 1989?
Your response must be concise. 0.92. What is the ratio of the No. of subscribers (per 100 people) of Barbados in 1987 to that in 1989?
Make the answer very short. 0.84. What is the ratio of the No. of subscribers (per 100 people) of Papua New Guinea in 1987 to that in 1989?
Keep it short and to the point. 1.03. What is the ratio of the No. of subscribers (per 100 people) in Sub-Saharan Africa (developing only) in 1987 to that in 1990?
Give a very brief answer. 0.88. What is the ratio of the No. of subscribers (per 100 people) of Barbados in 1987 to that in 1990?
Give a very brief answer. 0.77. What is the ratio of the No. of subscribers (per 100 people) in Papua New Guinea in 1987 to that in 1990?
Ensure brevity in your answer.  1.08. What is the ratio of the No. of subscribers (per 100 people) in Sub-Saharan Africa (developing only) in 1987 to that in 1991?
Offer a terse response. 0.87. What is the ratio of the No. of subscribers (per 100 people) in Barbados in 1987 to that in 1991?
Give a very brief answer. 0.72. What is the ratio of the No. of subscribers (per 100 people) in Papua New Guinea in 1987 to that in 1991?
Offer a very short reply. 0.99. What is the ratio of the No. of subscribers (per 100 people) of Sub-Saharan Africa (developing only) in 1988 to that in 1989?
Provide a short and direct response. 0.96. What is the ratio of the No. of subscribers (per 100 people) in Barbados in 1988 to that in 1989?
Keep it short and to the point. 0.9. What is the ratio of the No. of subscribers (per 100 people) of Papua New Guinea in 1988 to that in 1989?
Give a very brief answer. 1.02. What is the ratio of the No. of subscribers (per 100 people) of Sub-Saharan Africa (developing only) in 1988 to that in 1990?
Provide a succinct answer. 0.92. What is the ratio of the No. of subscribers (per 100 people) of Barbados in 1988 to that in 1990?
Give a very brief answer. 0.83. What is the ratio of the No. of subscribers (per 100 people) in Papua New Guinea in 1988 to that in 1990?
Your response must be concise. 1.08. What is the ratio of the No. of subscribers (per 100 people) of Sub-Saharan Africa (developing only) in 1988 to that in 1991?
Keep it short and to the point. 0.9. What is the ratio of the No. of subscribers (per 100 people) in Barbados in 1988 to that in 1991?
Make the answer very short. 0.77. What is the ratio of the No. of subscribers (per 100 people) of Papua New Guinea in 1988 to that in 1991?
Give a very brief answer. 0.98. What is the ratio of the No. of subscribers (per 100 people) in Sub-Saharan Africa (developing only) in 1989 to that in 1990?
Provide a short and direct response. 0.96. What is the ratio of the No. of subscribers (per 100 people) in Barbados in 1989 to that in 1990?
Your answer should be very brief. 0.92. What is the ratio of the No. of subscribers (per 100 people) in Papua New Guinea in 1989 to that in 1990?
Give a very brief answer. 1.05. What is the ratio of the No. of subscribers (per 100 people) in Sub-Saharan Africa (developing only) in 1989 to that in 1991?
Offer a very short reply. 0.94. What is the ratio of the No. of subscribers (per 100 people) of Barbados in 1989 to that in 1991?
Your answer should be compact. 0.85. What is the ratio of the No. of subscribers (per 100 people) of Papua New Guinea in 1989 to that in 1991?
Give a very brief answer. 0.96. What is the ratio of the No. of subscribers (per 100 people) in Sub-Saharan Africa (developing only) in 1990 to that in 1991?
Ensure brevity in your answer.  0.98. What is the ratio of the No. of subscribers (per 100 people) of Barbados in 1990 to that in 1991?
Provide a succinct answer. 0.93. What is the ratio of the No. of subscribers (per 100 people) in Papua New Guinea in 1990 to that in 1991?
Give a very brief answer. 0.91. What is the difference between the highest and the second highest No. of subscribers (per 100 people) of Sub-Saharan Africa (developing only)?
Offer a very short reply. 0.02. What is the difference between the highest and the second highest No. of subscribers (per 100 people) in Barbados?
Offer a very short reply. 2.15. What is the difference between the highest and the second highest No. of subscribers (per 100 people) in Papua New Guinea?
Provide a succinct answer. 0.02. What is the difference between the highest and the lowest No. of subscribers (per 100 people) of Sub-Saharan Africa (developing only)?
Provide a succinct answer. 0.23. What is the difference between the highest and the lowest No. of subscribers (per 100 people) of Barbados?
Your answer should be compact. 11.78. What is the difference between the highest and the lowest No. of subscribers (per 100 people) in Papua New Guinea?
Provide a short and direct response. 0.09. 